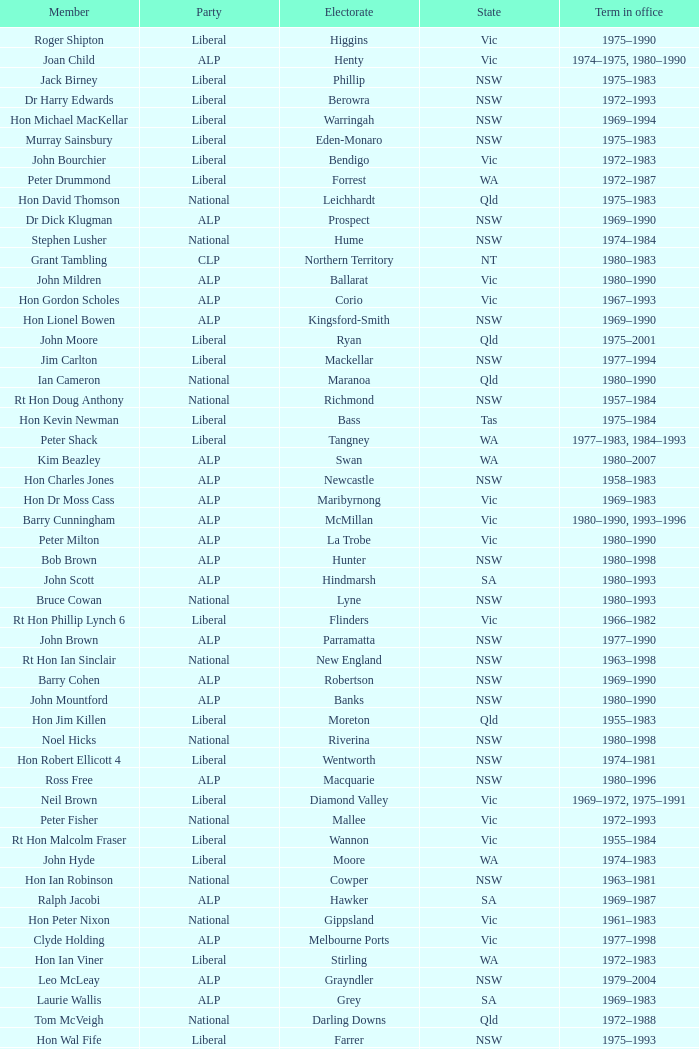What party is Mick Young a member of? ALP. 